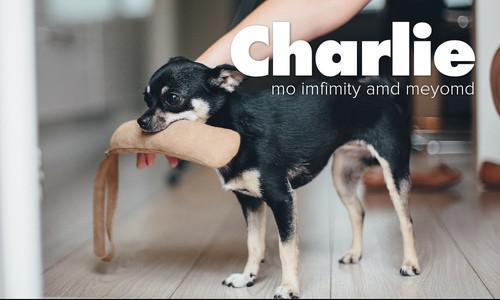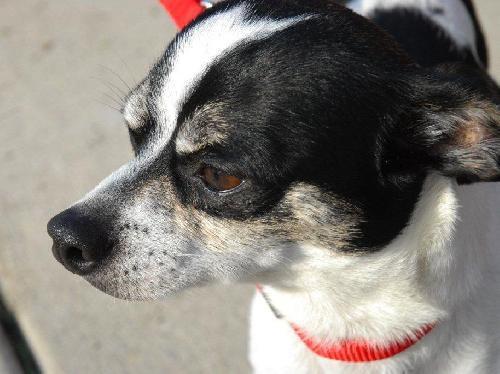The first image is the image on the left, the second image is the image on the right. Given the left and right images, does the statement "Each image contains exactly one dog, and the right image features a black-and-white dog wearing a red collar." hold true? Answer yes or no. Yes. The first image is the image on the left, the second image is the image on the right. For the images shown, is this caption "The right image contains a black and white chihuahua that is wearing a red collar." true? Answer yes or no. Yes. 